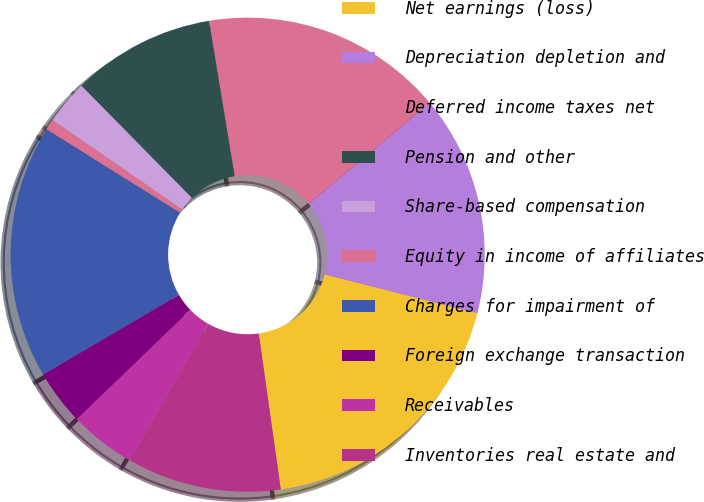Convert chart to OTSL. <chart><loc_0><loc_0><loc_500><loc_500><pie_chart><fcel>Net earnings (loss)<fcel>Depreciation depletion and<fcel>Deferred income taxes net<fcel>Pension and other<fcel>Share-based compensation<fcel>Equity in income of affiliates<fcel>Charges for impairment of<fcel>Foreign exchange transaction<fcel>Receivables<fcel>Inventories real estate and<nl><fcel>18.79%<fcel>15.04%<fcel>16.54%<fcel>9.77%<fcel>3.01%<fcel>0.76%<fcel>17.29%<fcel>3.76%<fcel>4.51%<fcel>10.53%<nl></chart> 